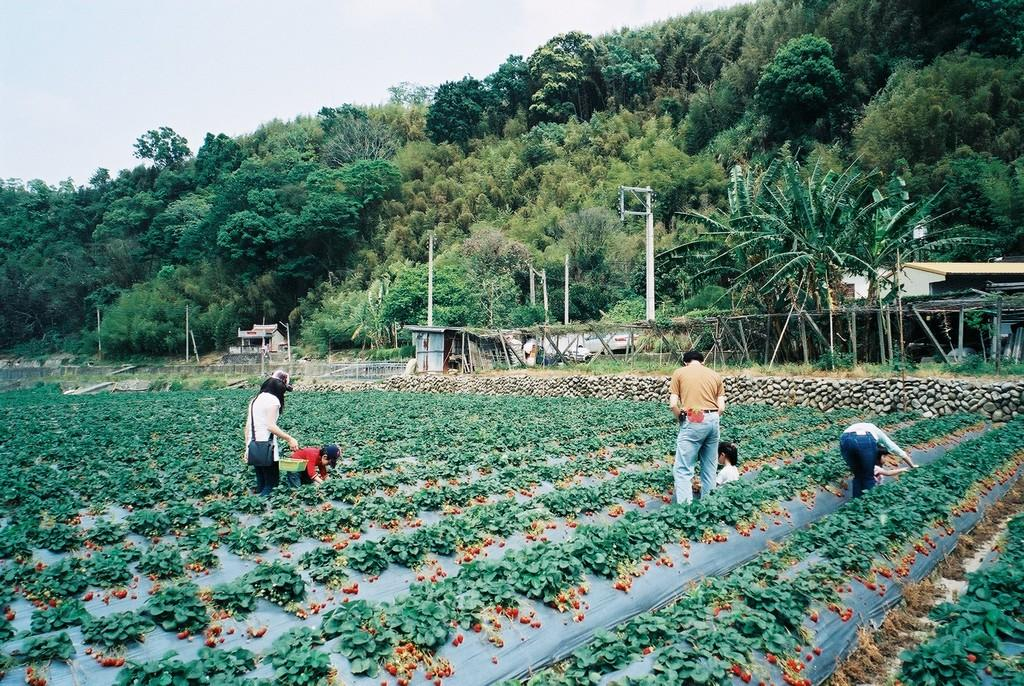Who are the subjects in the image? There are people in the image. What are the people doing in the image? The people are picking cherries from plants. Can you describe the positions of some people in the image? Some people are standing. What can be seen in the background of the image? There are trees, plants, buildings, and sheds in the background of the image. What type of toys can be seen in the image? There are no toys present in the image. Is this a family gathering to pick cherries? The provided facts do not mention the relationship between the people in the image, so we cannot determine if it is a family gathering. 